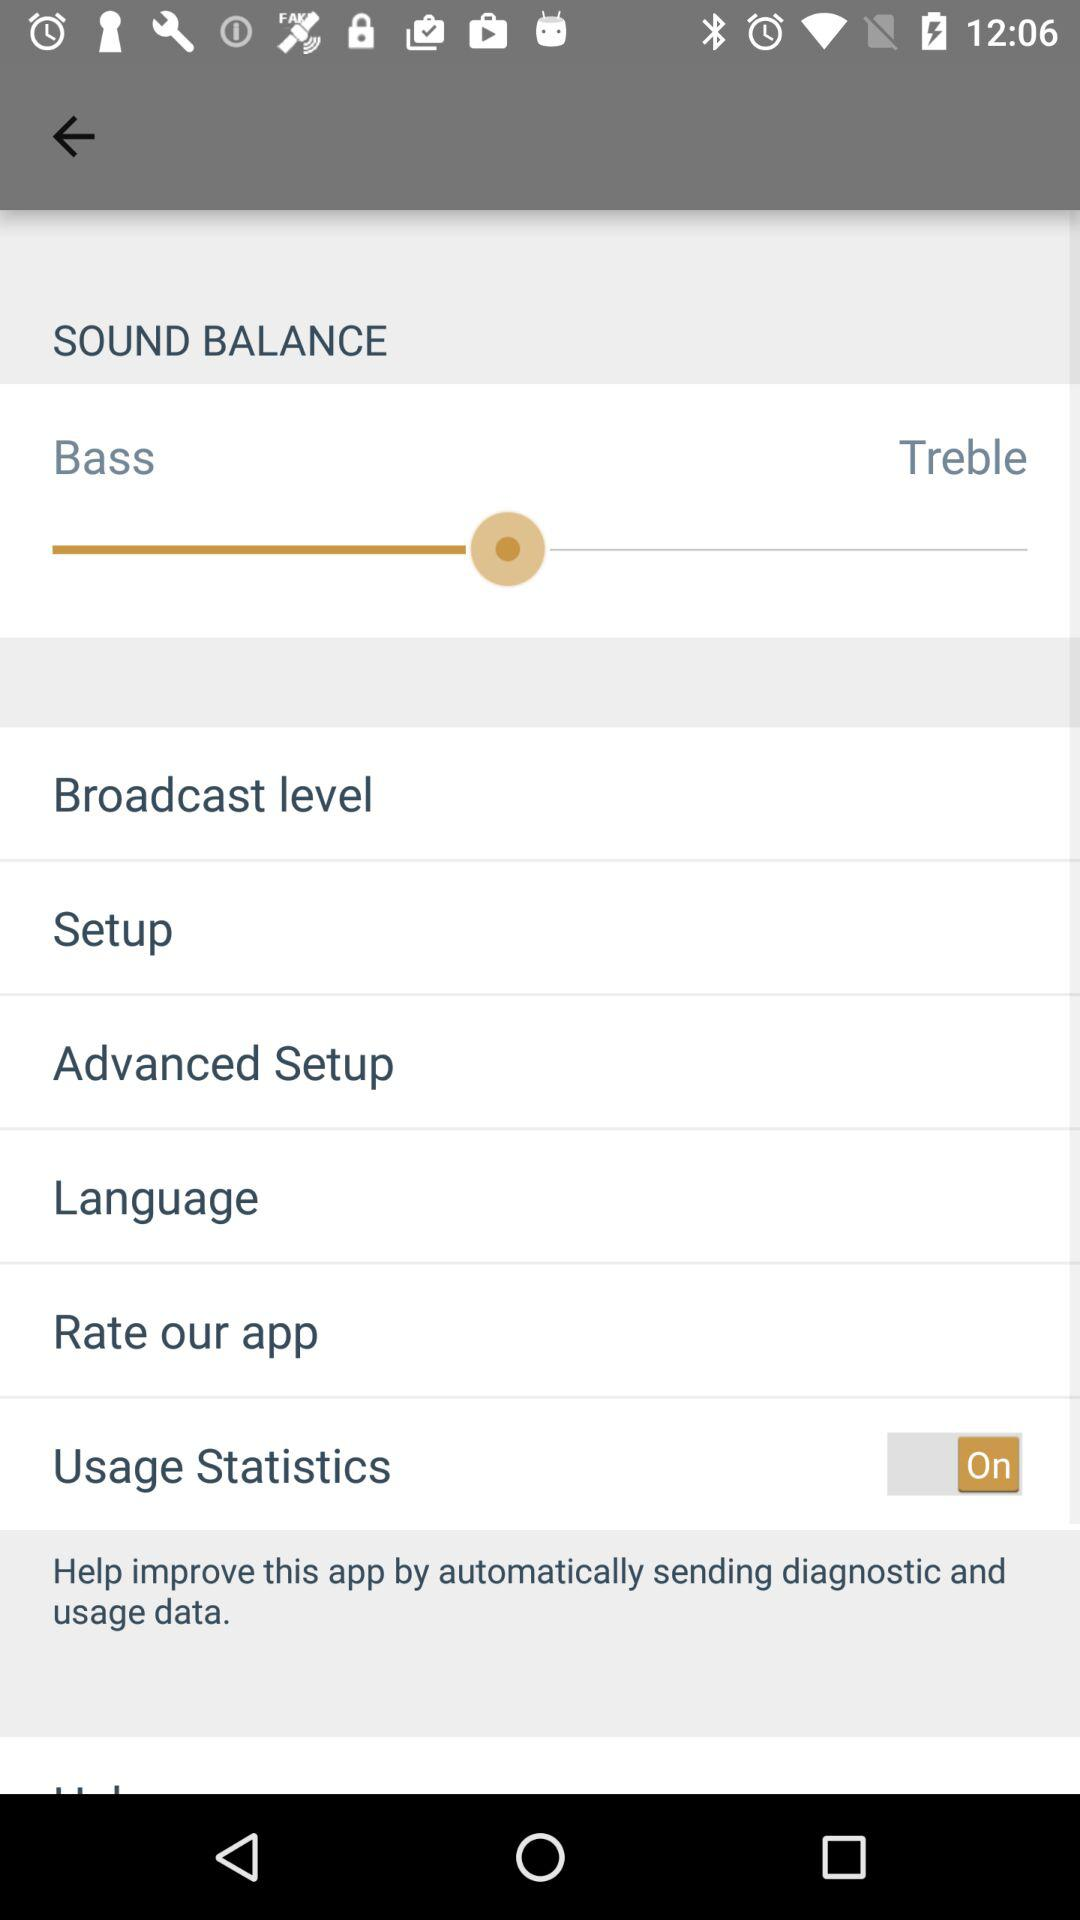How many items are below the Sound Balance header?
Answer the question using a single word or phrase. 7 